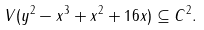Convert formula to latex. <formula><loc_0><loc_0><loc_500><loc_500>V ( y ^ { 2 } - x ^ { 3 } + x ^ { 2 } + 1 6 x ) \subseteq C ^ { 2 } .</formula> 